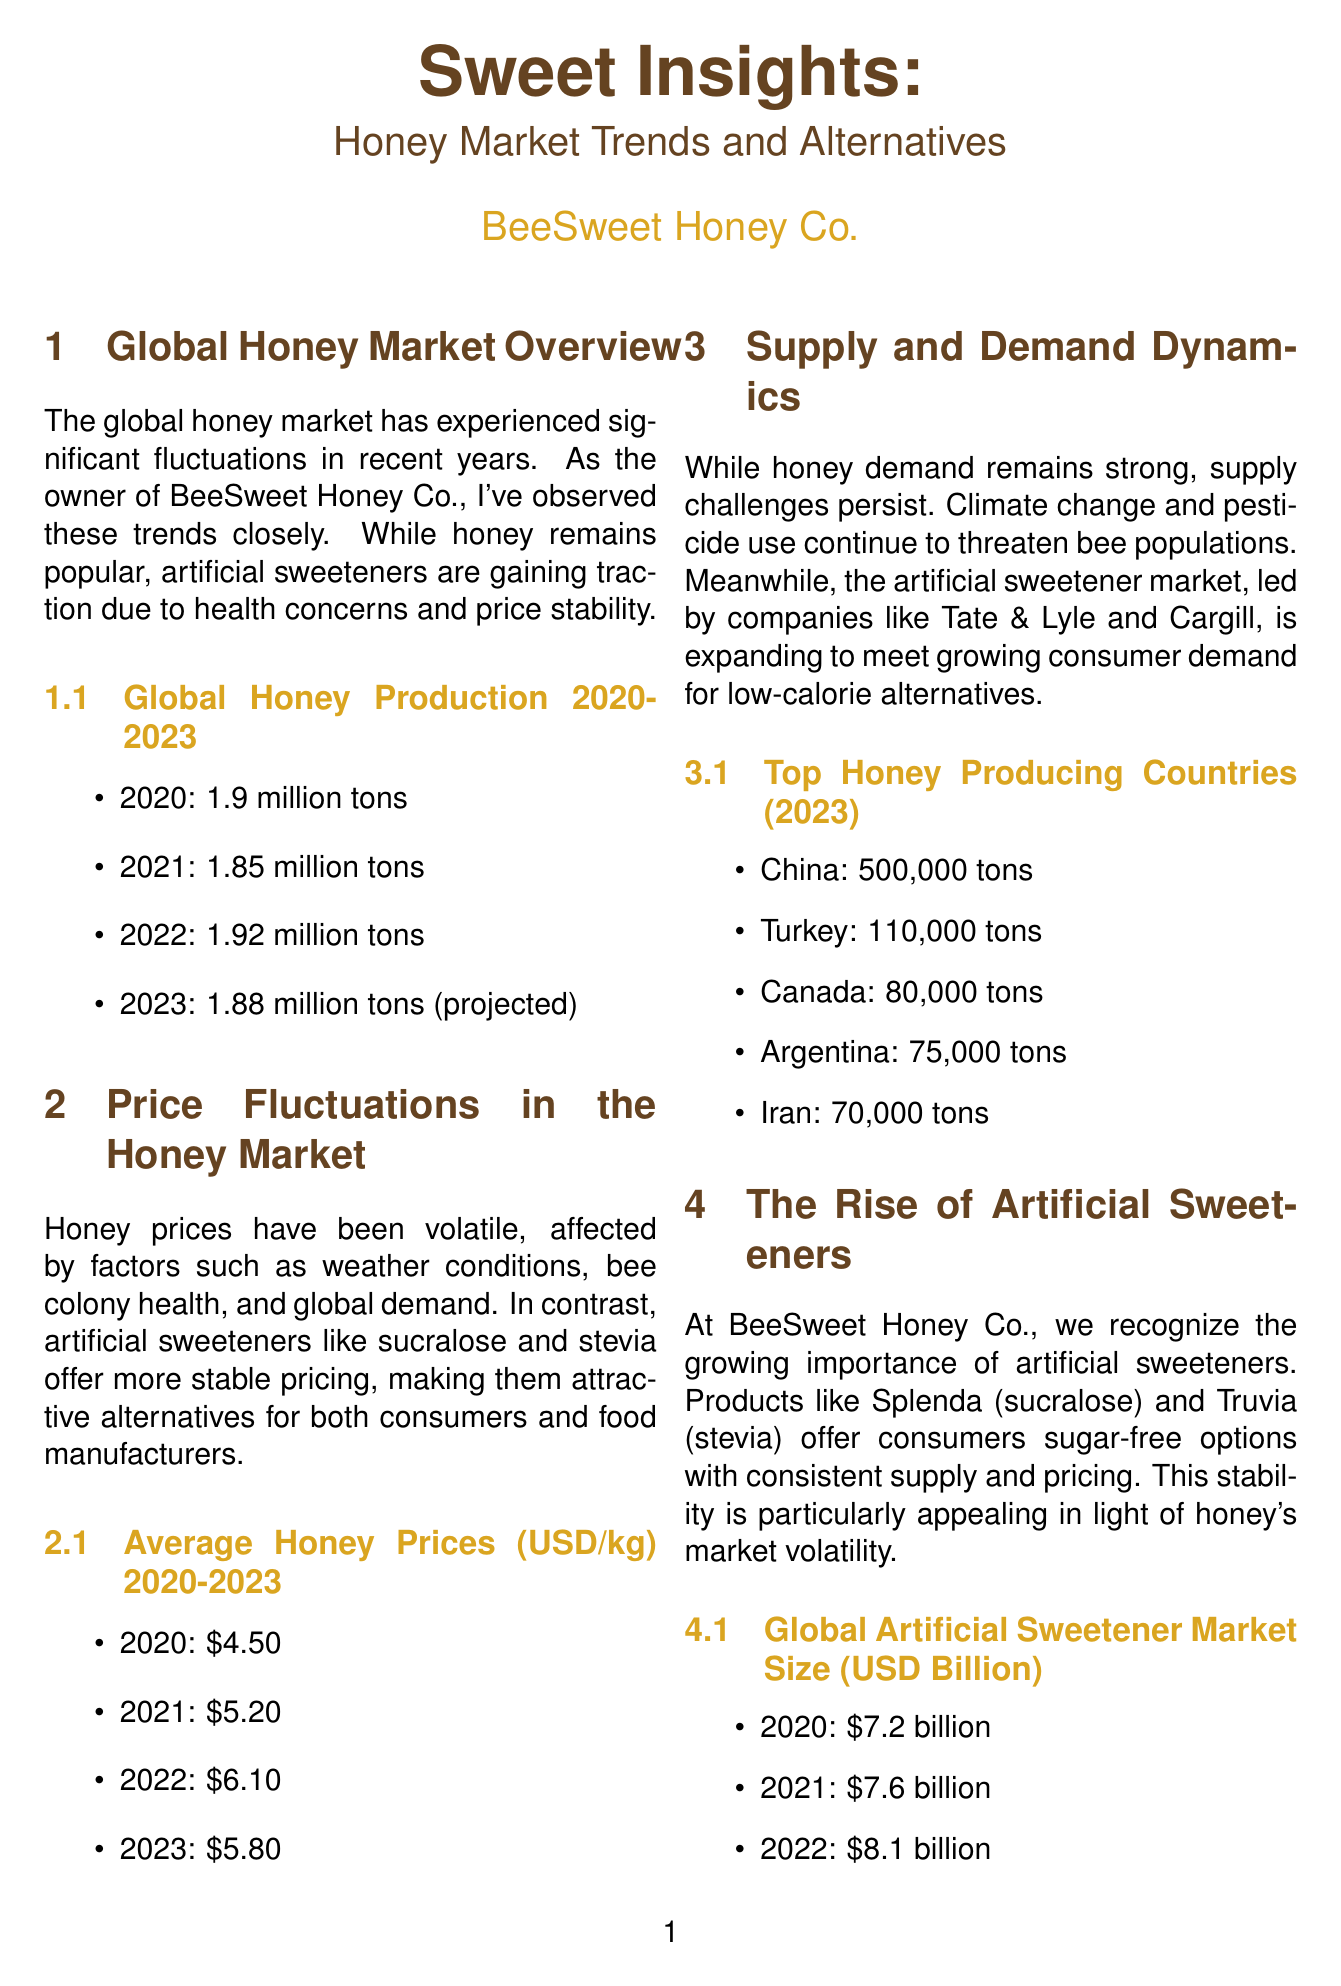what was the global honey production in 2022? The document states that the global honey production in 2022 was 1.92 million tons.
Answer: 1.92 million tons what is the average honey price in 2021? According to the price fluctuations section, the average honey price in 2021 was 5.20 USD/kg.
Answer: 5.20 USD/kg which country is the top honey producer in 2023? The infographic on top honey producing countries indicates that China is the top honey producer in 2023.
Answer: China what is the projected global artificial sweetener market size for 2024? The document provides the projected market size for 2024, which is stated as 9.2 billion USD.
Answer: 9.2 billion USD which sweetener products are mentioned in the newsletter? The newsletter highlights Splenda (sucralose) and Truvia (stevia) as artificial sweetener products.
Answer: Splenda, Truvia how many tons of honey does Turkey produce in 2023? The infographic states that Turkey produces 110,000 tons of honey in 2023.
Answer: 110,000 tons what is one of the challenges to honey supply mentioned? The document mentions climate change as a challenge to honey supply.
Answer: Climate change what is the key focus for BeeSweet Honey Co. in the future? The newsletter mentions that BeeSweet Honey Co. is focusing on diversifying their product line.
Answer: Diversifying product line 